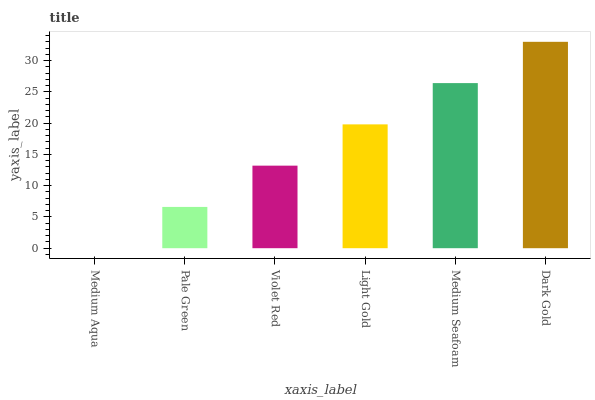Is Pale Green the minimum?
Answer yes or no. No. Is Pale Green the maximum?
Answer yes or no. No. Is Pale Green greater than Medium Aqua?
Answer yes or no. Yes. Is Medium Aqua less than Pale Green?
Answer yes or no. Yes. Is Medium Aqua greater than Pale Green?
Answer yes or no. No. Is Pale Green less than Medium Aqua?
Answer yes or no. No. Is Light Gold the high median?
Answer yes or no. Yes. Is Violet Red the low median?
Answer yes or no. Yes. Is Dark Gold the high median?
Answer yes or no. No. Is Light Gold the low median?
Answer yes or no. No. 